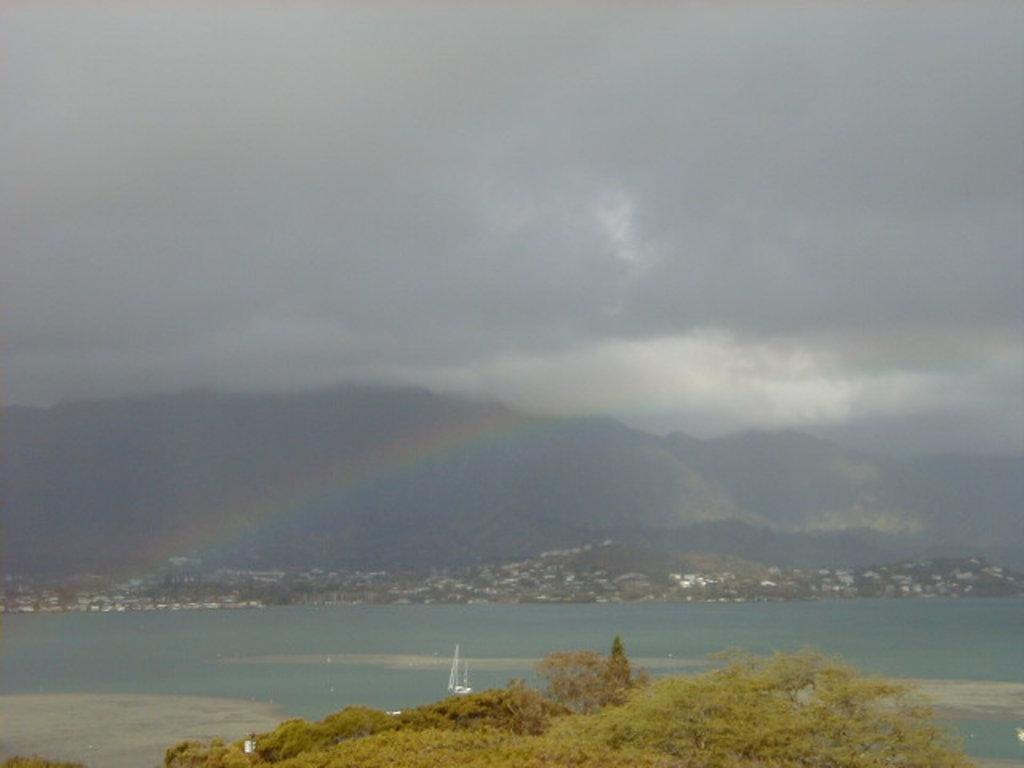What type of landscape is visible at the bottom side of the image? There is greenery at the bottom side of the image, which includes houses and trees. What can be seen in the sky at the top side of the image? The sky is visible at the top side of the image. How is the image taken, providing this view? The image appears to be an aerial view. Are there any fish visible in the greenery at the bottom side of the image? There are no fish present in the image; it features greenery, houses, and trees. What type of spark can be seen in the sky at the top side of the image? There is no spark visible in the sky at the top side of the image; it is a clear sky. 